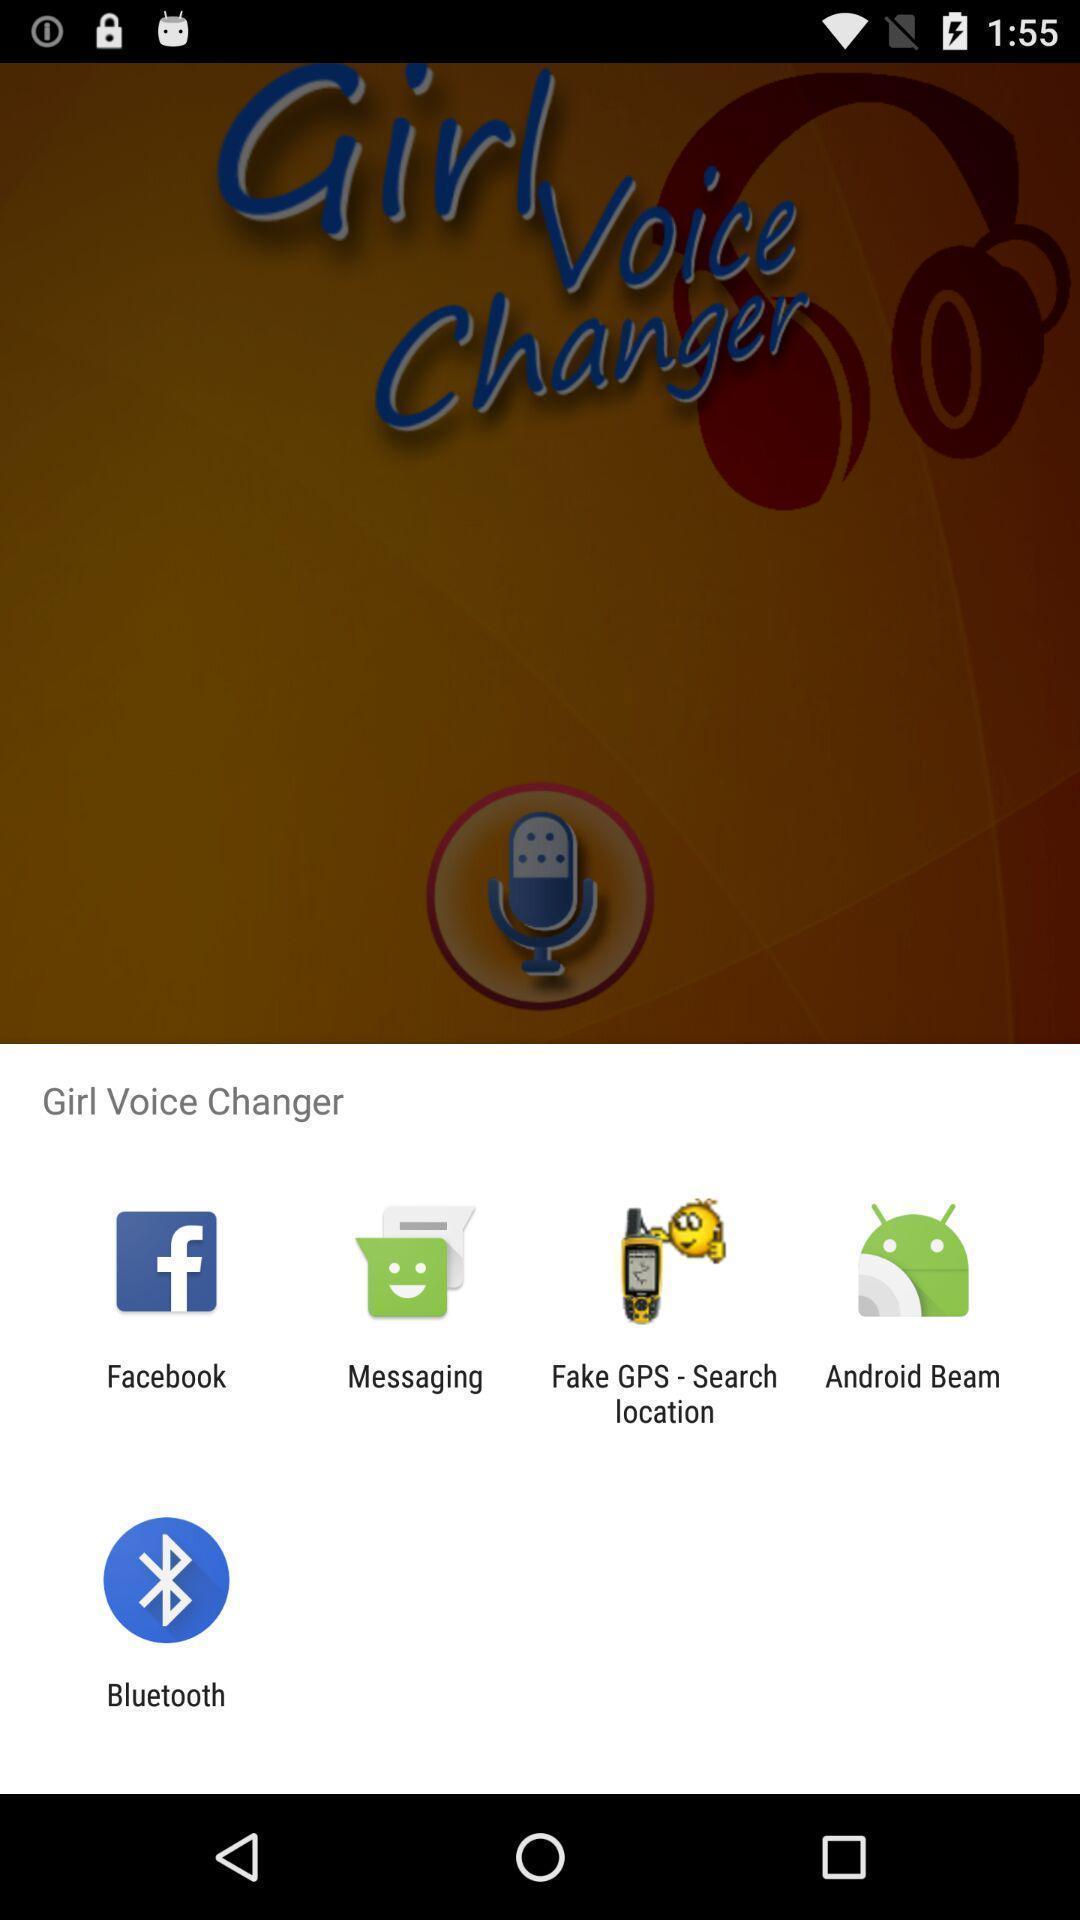Explain what's happening in this screen capture. Widget is showing different sharing apps. 